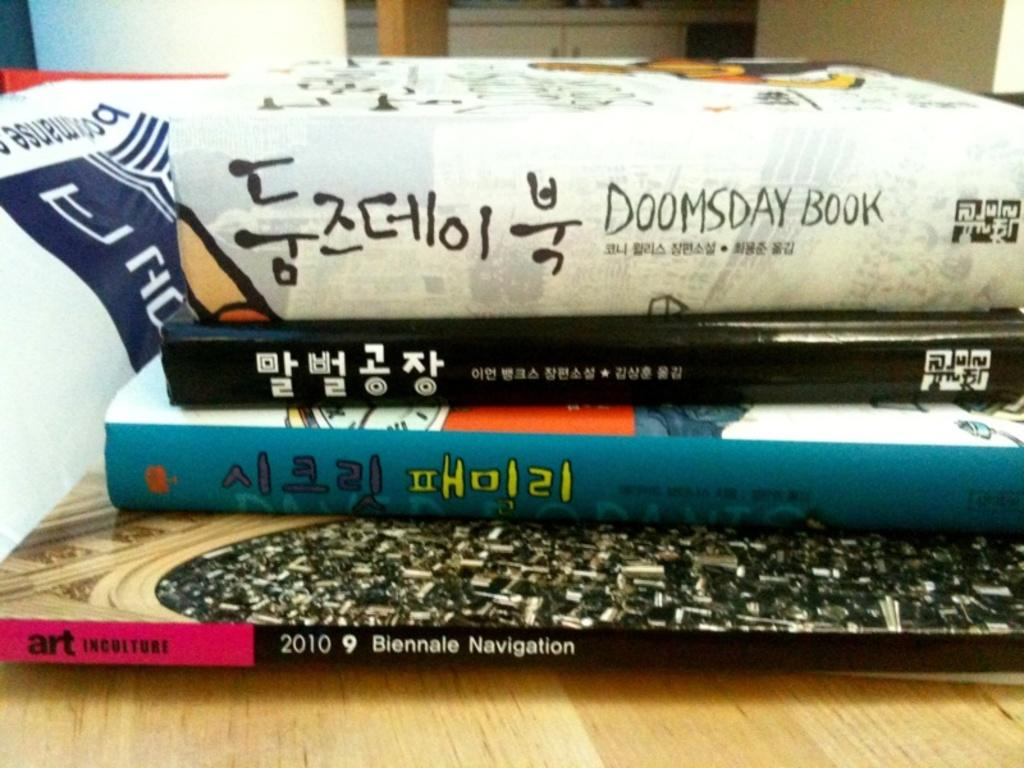<image>
Render a clear and concise summary of the photo. A stack of books including one called Doomsday Book. 